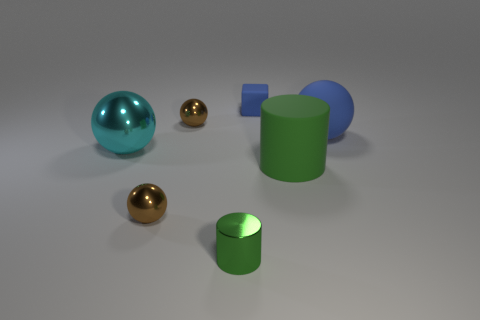Subtract all brown cubes. How many brown spheres are left? 2 Subtract all cyan balls. How many balls are left? 3 Subtract all matte spheres. How many spheres are left? 3 Subtract 1 balls. How many balls are left? 3 Subtract all gray spheres. Subtract all cyan blocks. How many spheres are left? 4 Add 1 big green matte things. How many objects exist? 8 Subtract all spheres. How many objects are left? 3 Subtract 0 yellow cubes. How many objects are left? 7 Subtract all purple cylinders. Subtract all large green things. How many objects are left? 6 Add 4 blue matte balls. How many blue matte balls are left? 5 